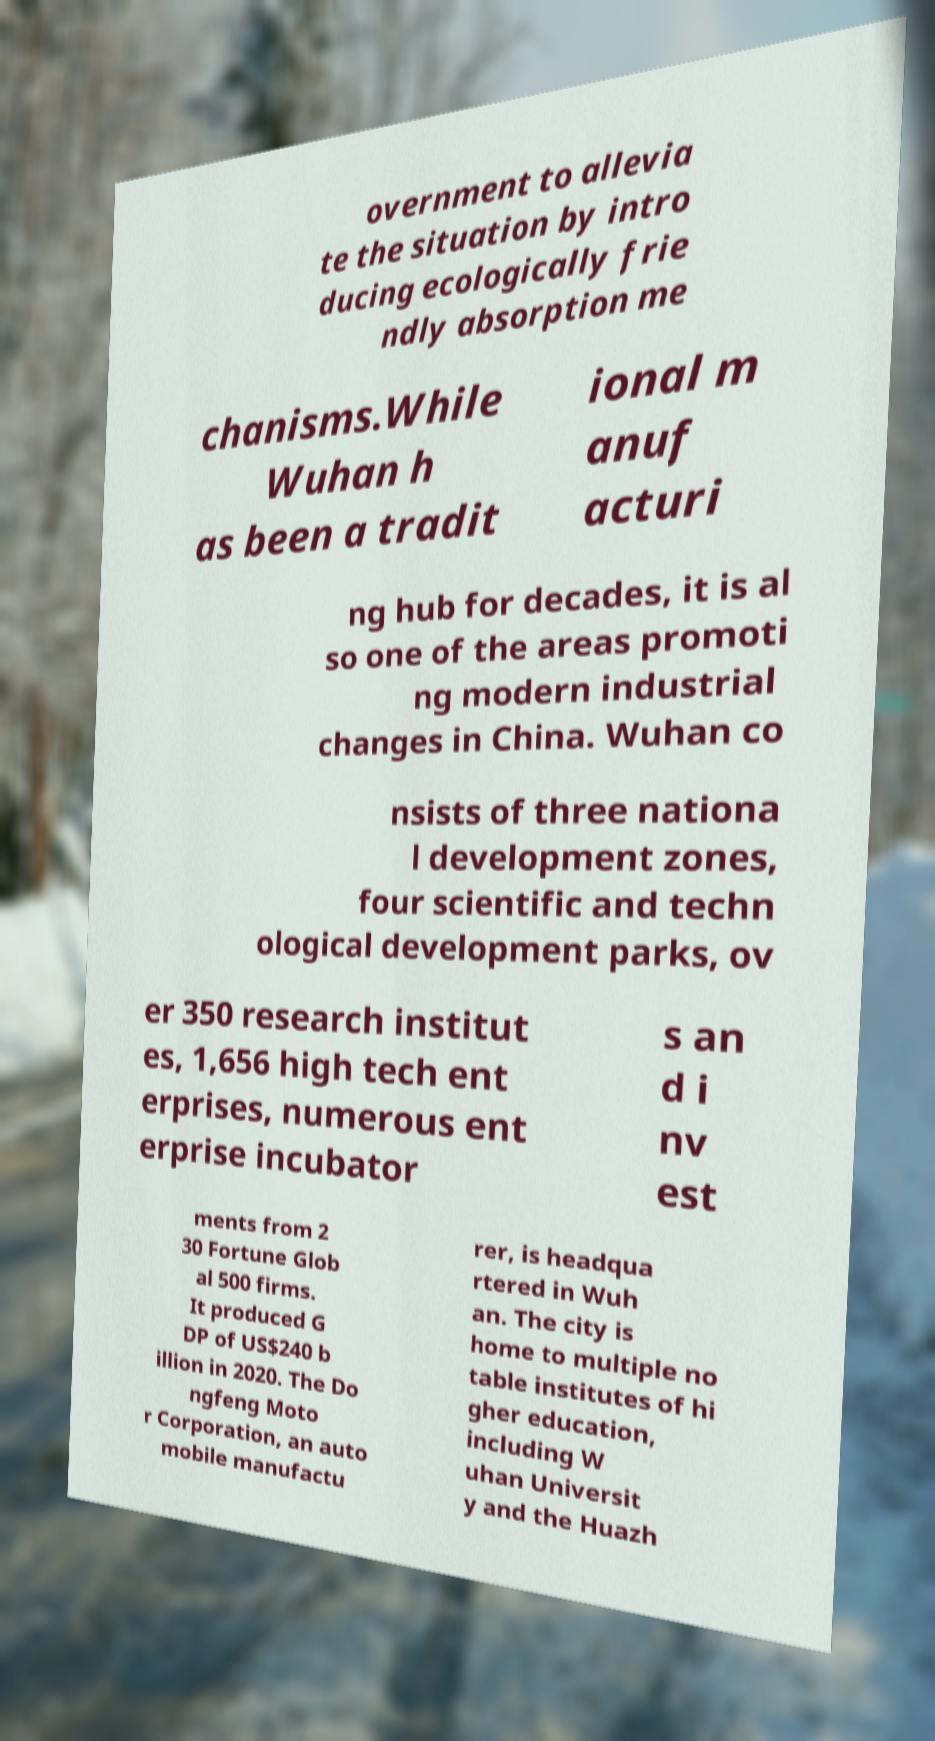Could you extract and type out the text from this image? overnment to allevia te the situation by intro ducing ecologically frie ndly absorption me chanisms.While Wuhan h as been a tradit ional m anuf acturi ng hub for decades, it is al so one of the areas promoti ng modern industrial changes in China. Wuhan co nsists of three nationa l development zones, four scientific and techn ological development parks, ov er 350 research institut es, 1,656 high tech ent erprises, numerous ent erprise incubator s an d i nv est ments from 2 30 Fortune Glob al 500 firms. It produced G DP of US$240 b illion in 2020. The Do ngfeng Moto r Corporation, an auto mobile manufactu rer, is headqua rtered in Wuh an. The city is home to multiple no table institutes of hi gher education, including W uhan Universit y and the Huazh 